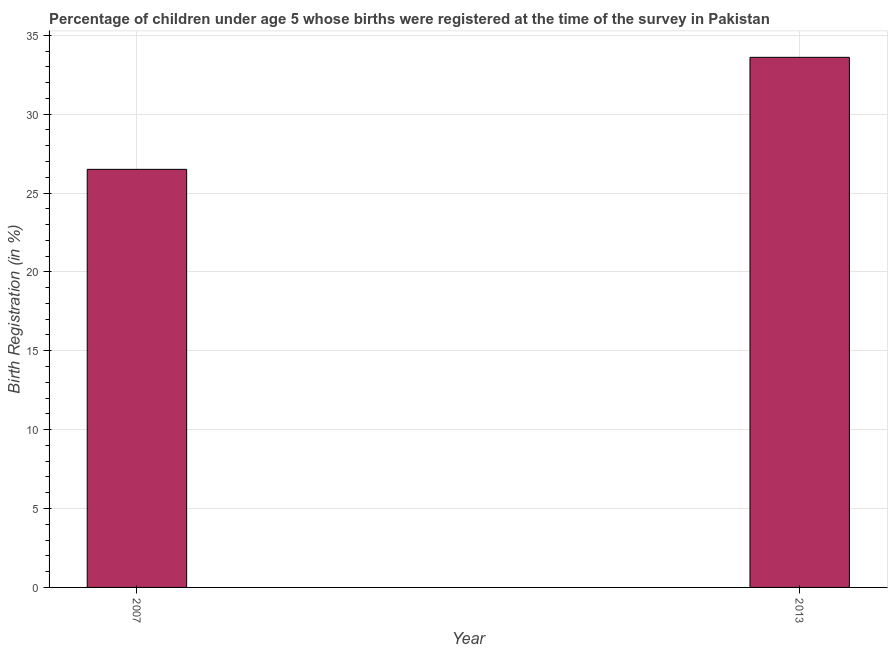What is the title of the graph?
Provide a short and direct response. Percentage of children under age 5 whose births were registered at the time of the survey in Pakistan. What is the label or title of the X-axis?
Ensure brevity in your answer.  Year. What is the label or title of the Y-axis?
Provide a short and direct response. Birth Registration (in %). What is the birth registration in 2013?
Offer a terse response. 33.6. Across all years, what is the maximum birth registration?
Give a very brief answer. 33.6. Across all years, what is the minimum birth registration?
Provide a succinct answer. 26.5. What is the sum of the birth registration?
Make the answer very short. 60.1. What is the average birth registration per year?
Your answer should be compact. 30.05. What is the median birth registration?
Make the answer very short. 30.05. In how many years, is the birth registration greater than 34 %?
Your answer should be compact. 0. Do a majority of the years between 2007 and 2013 (inclusive) have birth registration greater than 33 %?
Your answer should be compact. No. What is the ratio of the birth registration in 2007 to that in 2013?
Your answer should be compact. 0.79. Is the birth registration in 2007 less than that in 2013?
Your answer should be compact. Yes. In how many years, is the birth registration greater than the average birth registration taken over all years?
Provide a succinct answer. 1. How many years are there in the graph?
Provide a short and direct response. 2. What is the difference between two consecutive major ticks on the Y-axis?
Offer a very short reply. 5. Are the values on the major ticks of Y-axis written in scientific E-notation?
Ensure brevity in your answer.  No. What is the Birth Registration (in %) of 2013?
Your answer should be very brief. 33.6. What is the ratio of the Birth Registration (in %) in 2007 to that in 2013?
Ensure brevity in your answer.  0.79. 